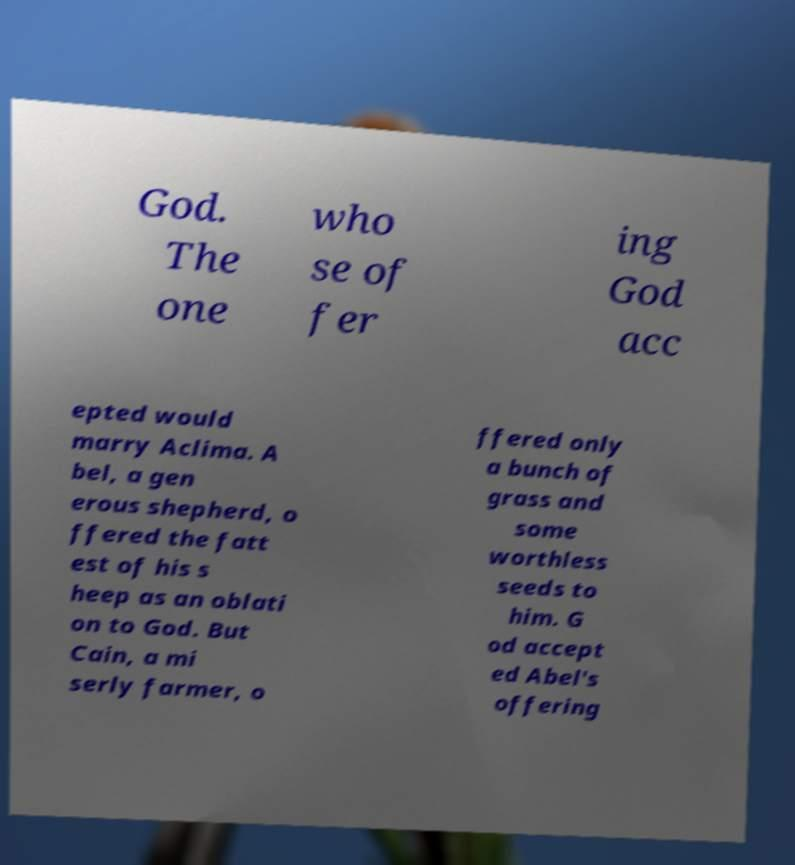For documentation purposes, I need the text within this image transcribed. Could you provide that? God. The one who se of fer ing God acc epted would marry Aclima. A bel, a gen erous shepherd, o ffered the fatt est of his s heep as an oblati on to God. But Cain, a mi serly farmer, o ffered only a bunch of grass and some worthless seeds to him. G od accept ed Abel's offering 